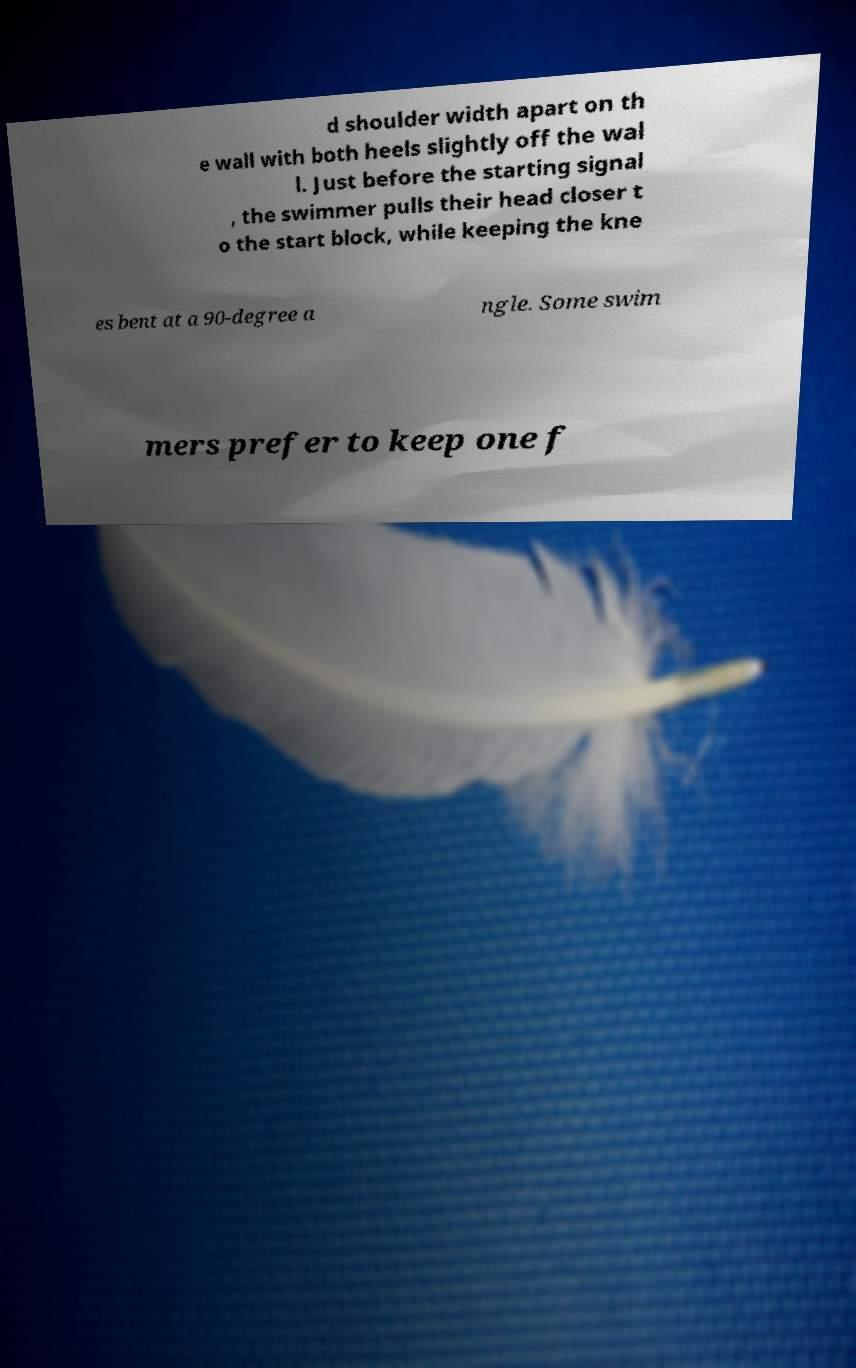I need the written content from this picture converted into text. Can you do that? d shoulder width apart on th e wall with both heels slightly off the wal l. Just before the starting signal , the swimmer pulls their head closer t o the start block, while keeping the kne es bent at a 90-degree a ngle. Some swim mers prefer to keep one f 